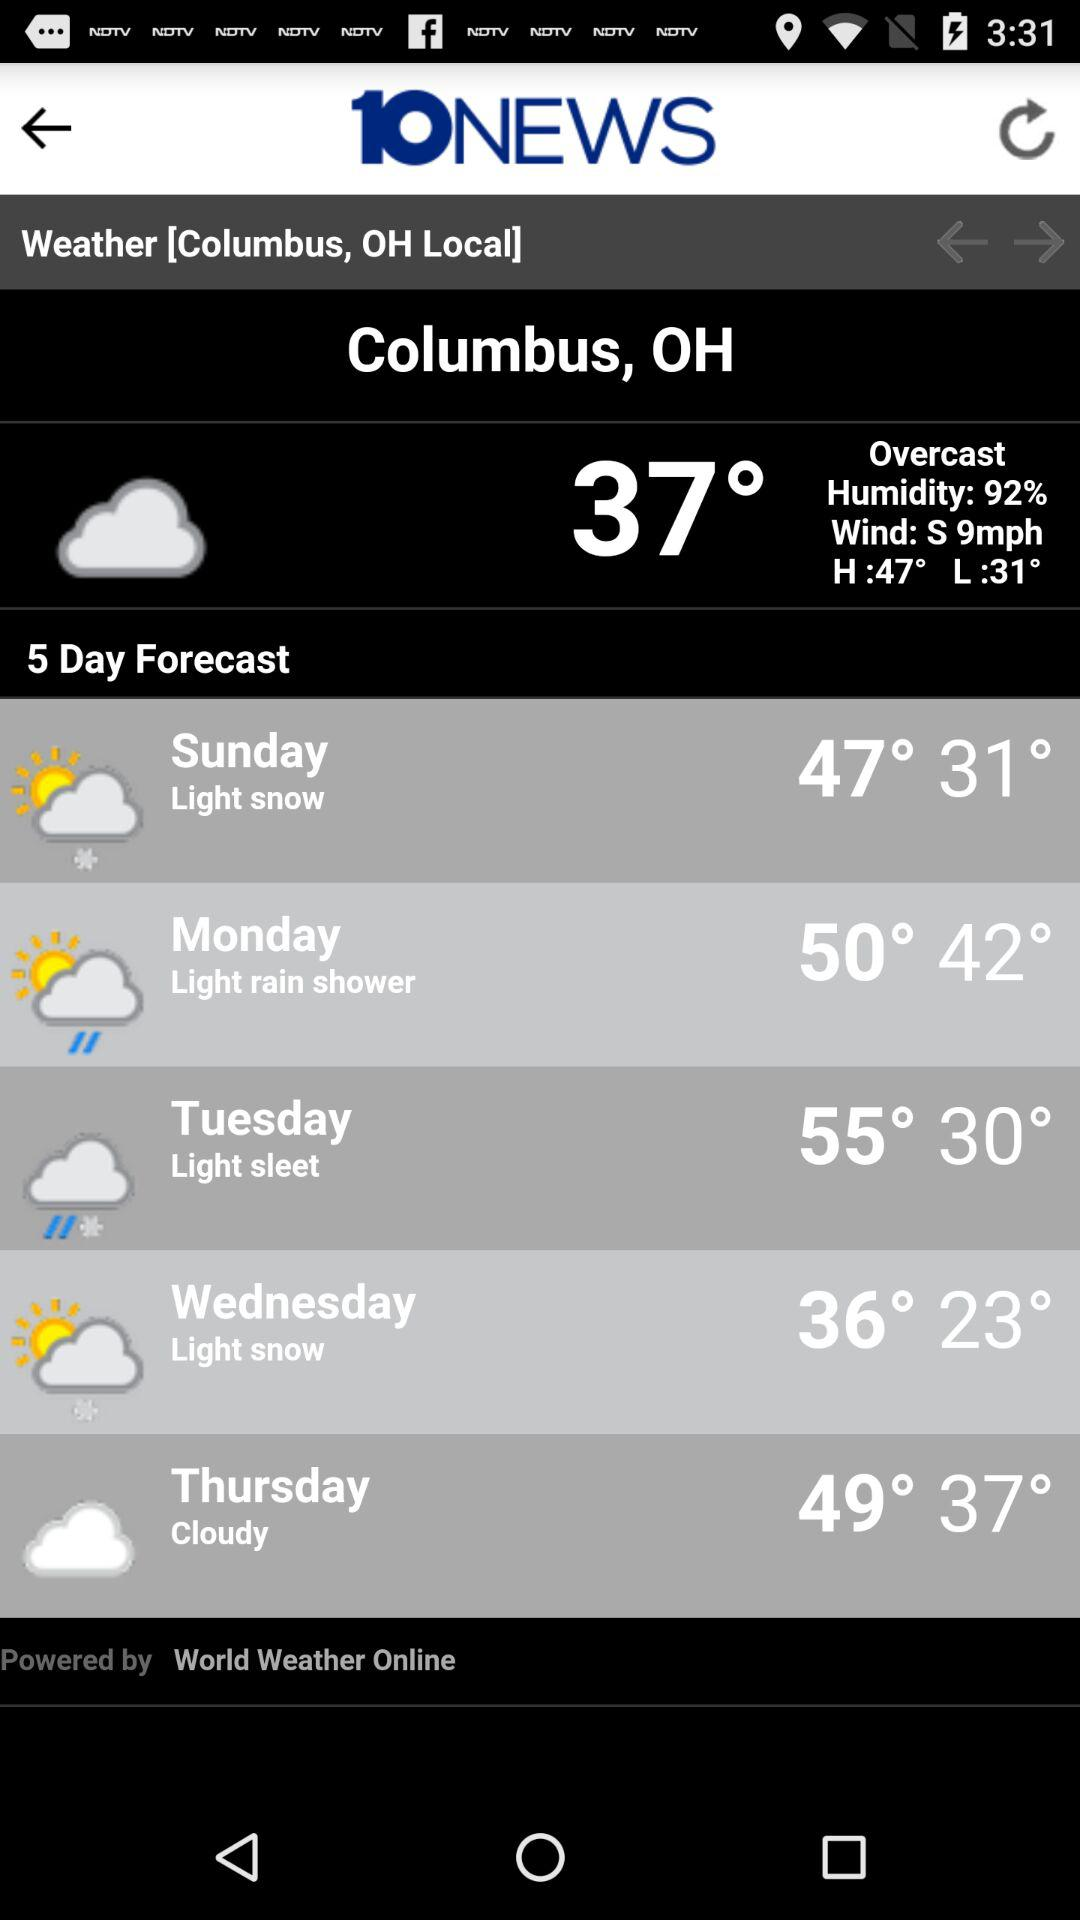What is the humidity percentage? The humidity is 92%. 